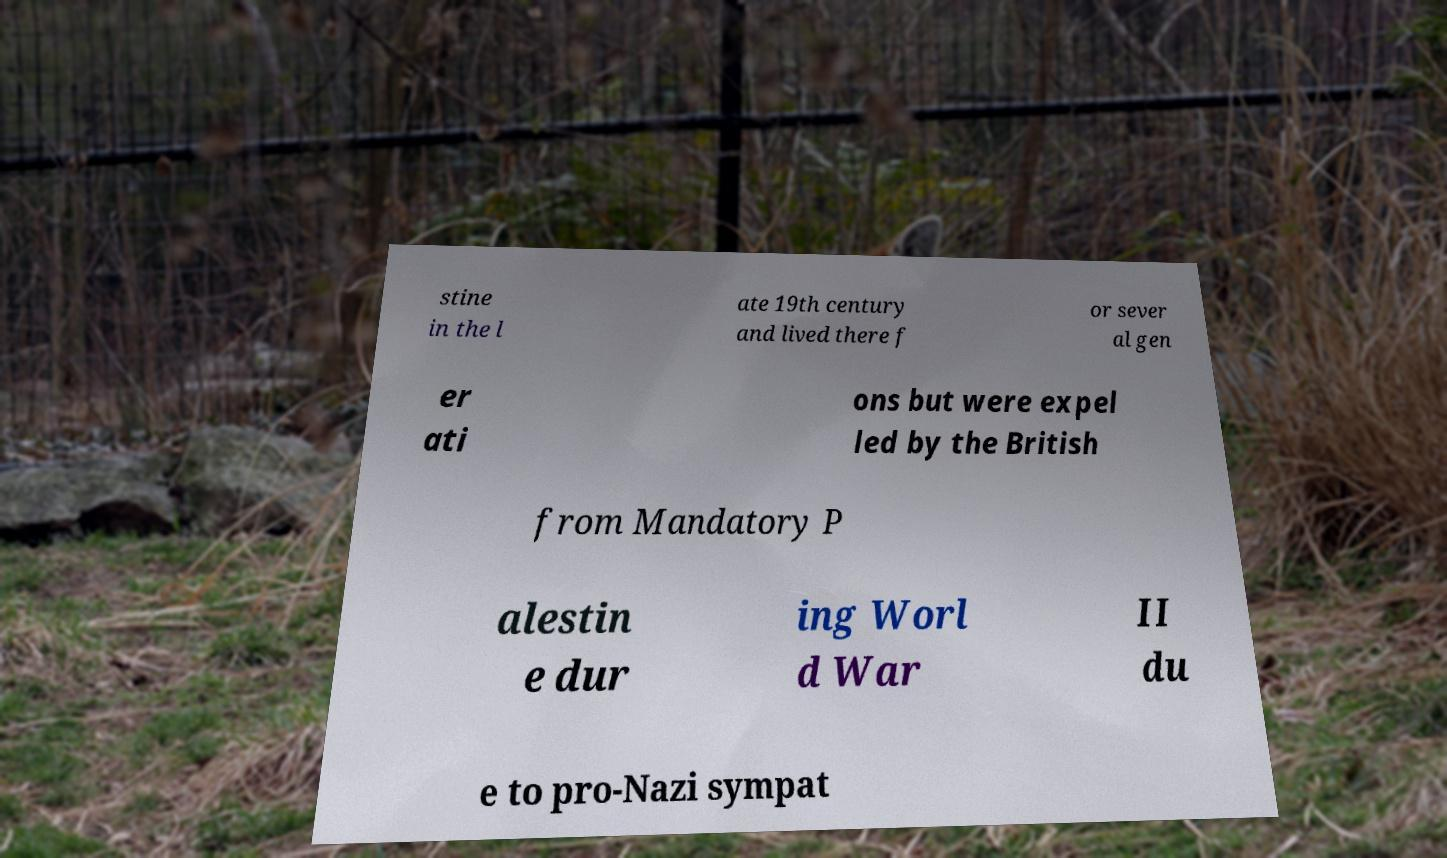Could you extract and type out the text from this image? stine in the l ate 19th century and lived there f or sever al gen er ati ons but were expel led by the British from Mandatory P alestin e dur ing Worl d War II du e to pro-Nazi sympat 